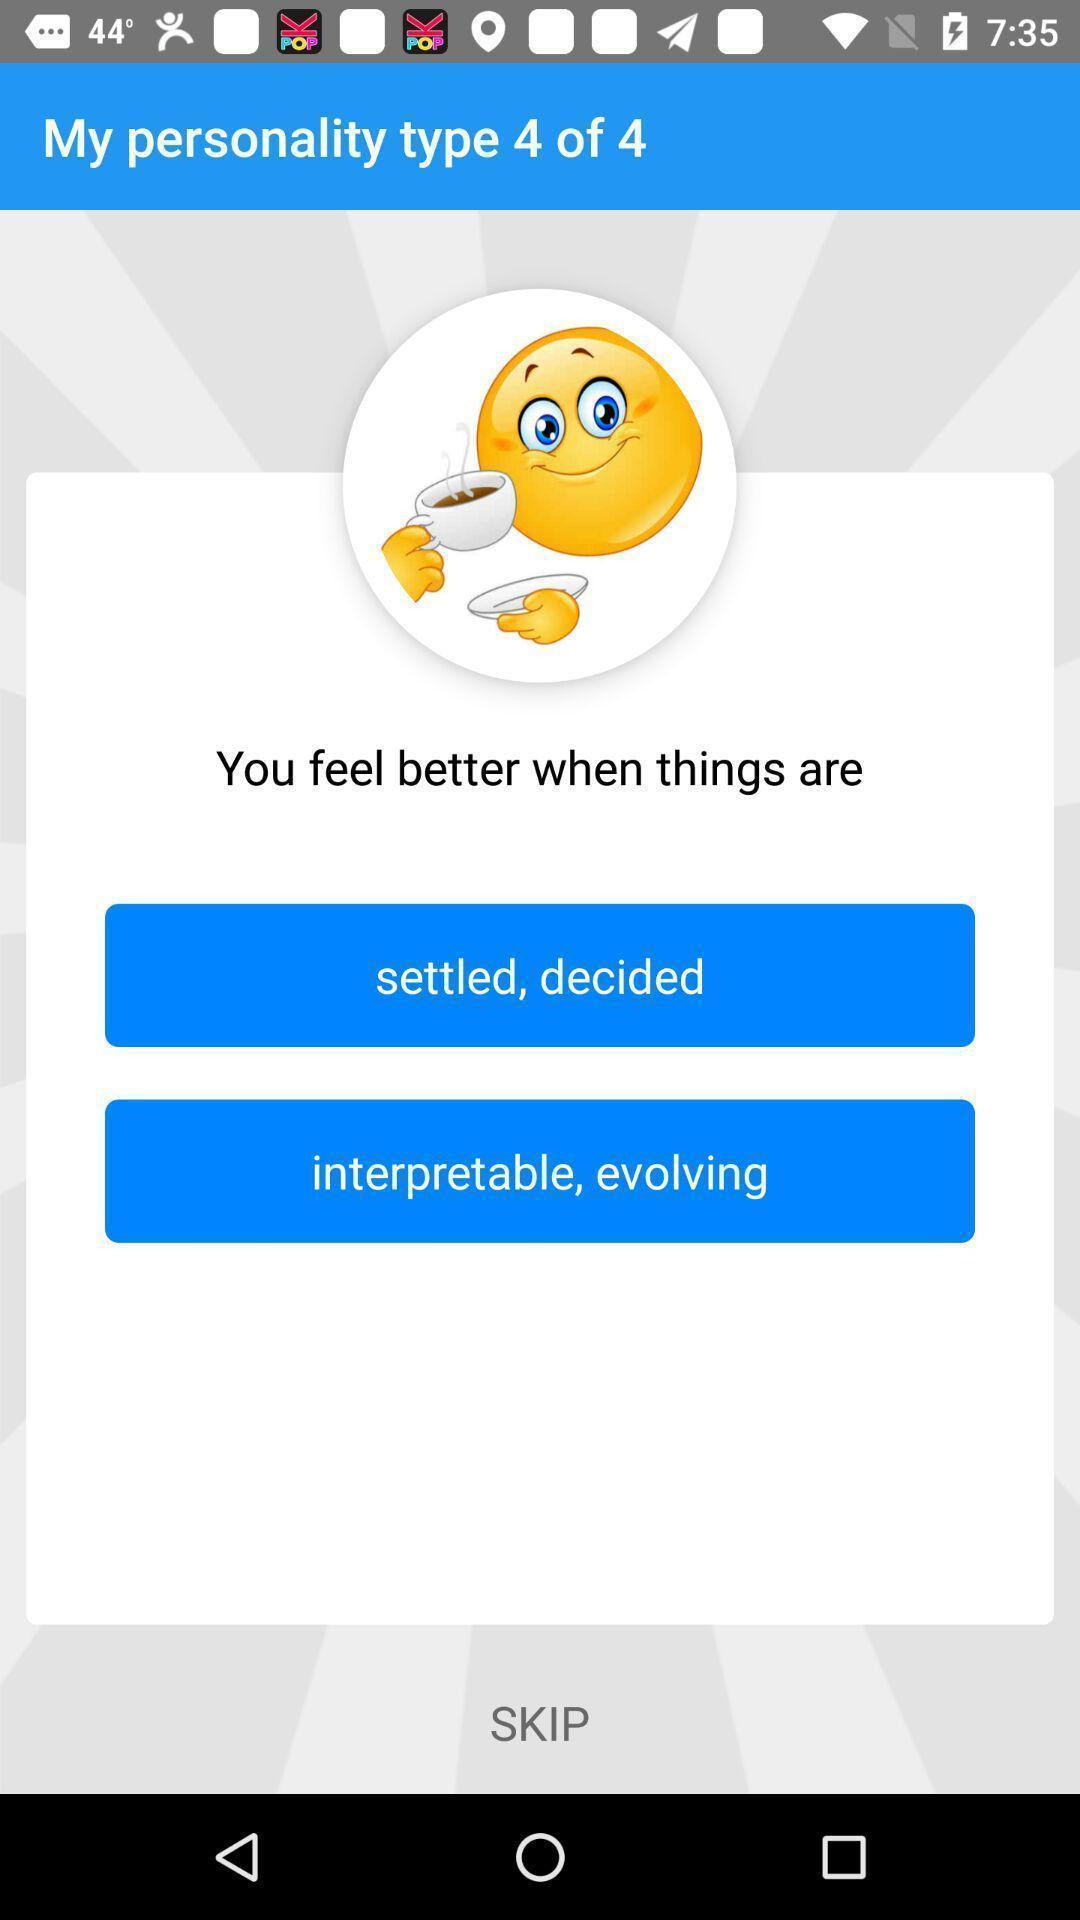What details can you identify in this image? Pop-up shows to select an option. 